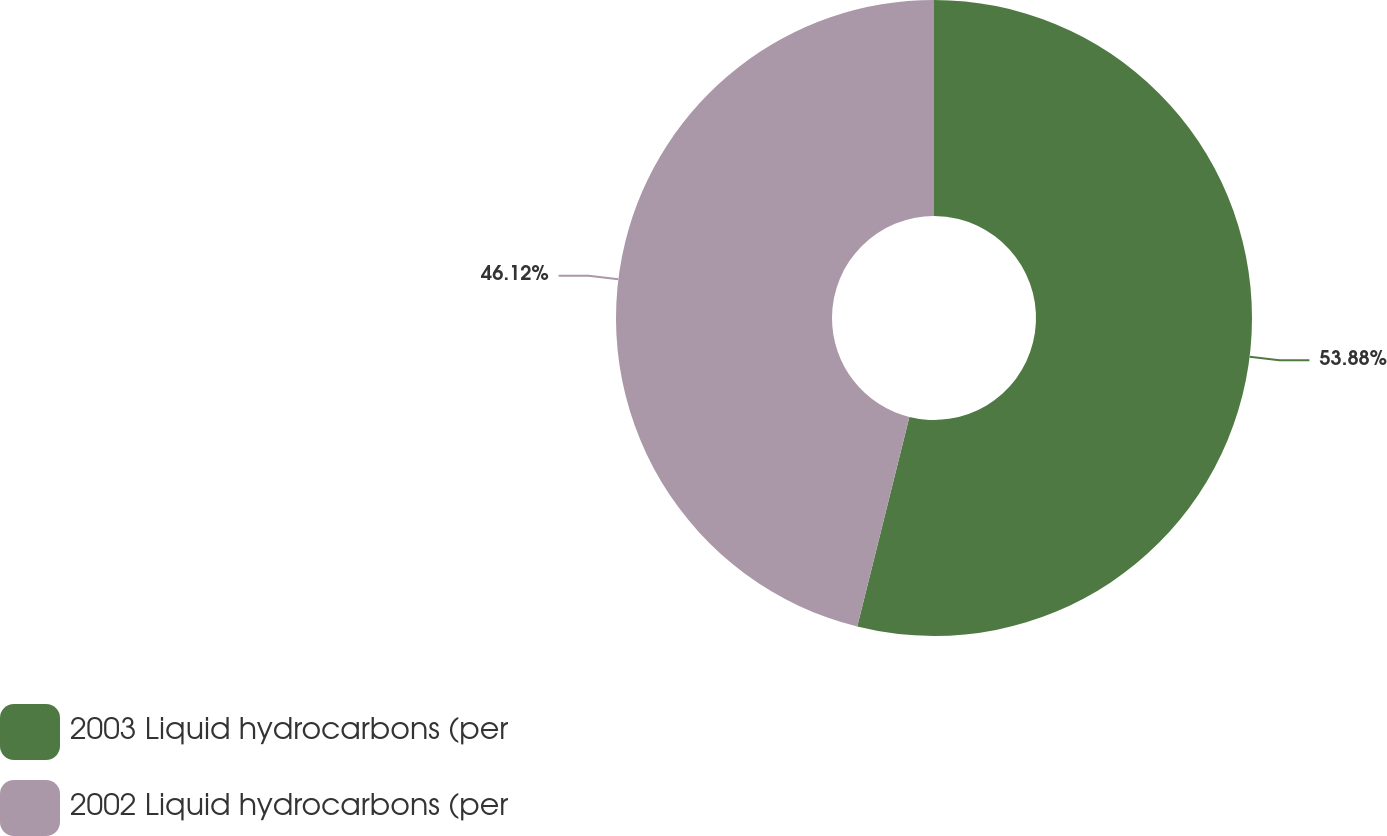Convert chart to OTSL. <chart><loc_0><loc_0><loc_500><loc_500><pie_chart><fcel>2003 Liquid hydrocarbons (per<fcel>2002 Liquid hydrocarbons (per<nl><fcel>53.88%<fcel>46.12%<nl></chart> 